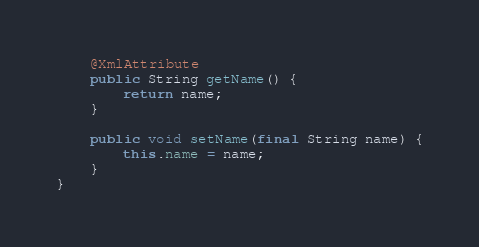Convert code to text. <code><loc_0><loc_0><loc_500><loc_500><_Java_>
	@XmlAttribute
	public String getName() {
		return name;
	}

	public void setName(final String name) {
		this.name = name;
	}
}
</code> 